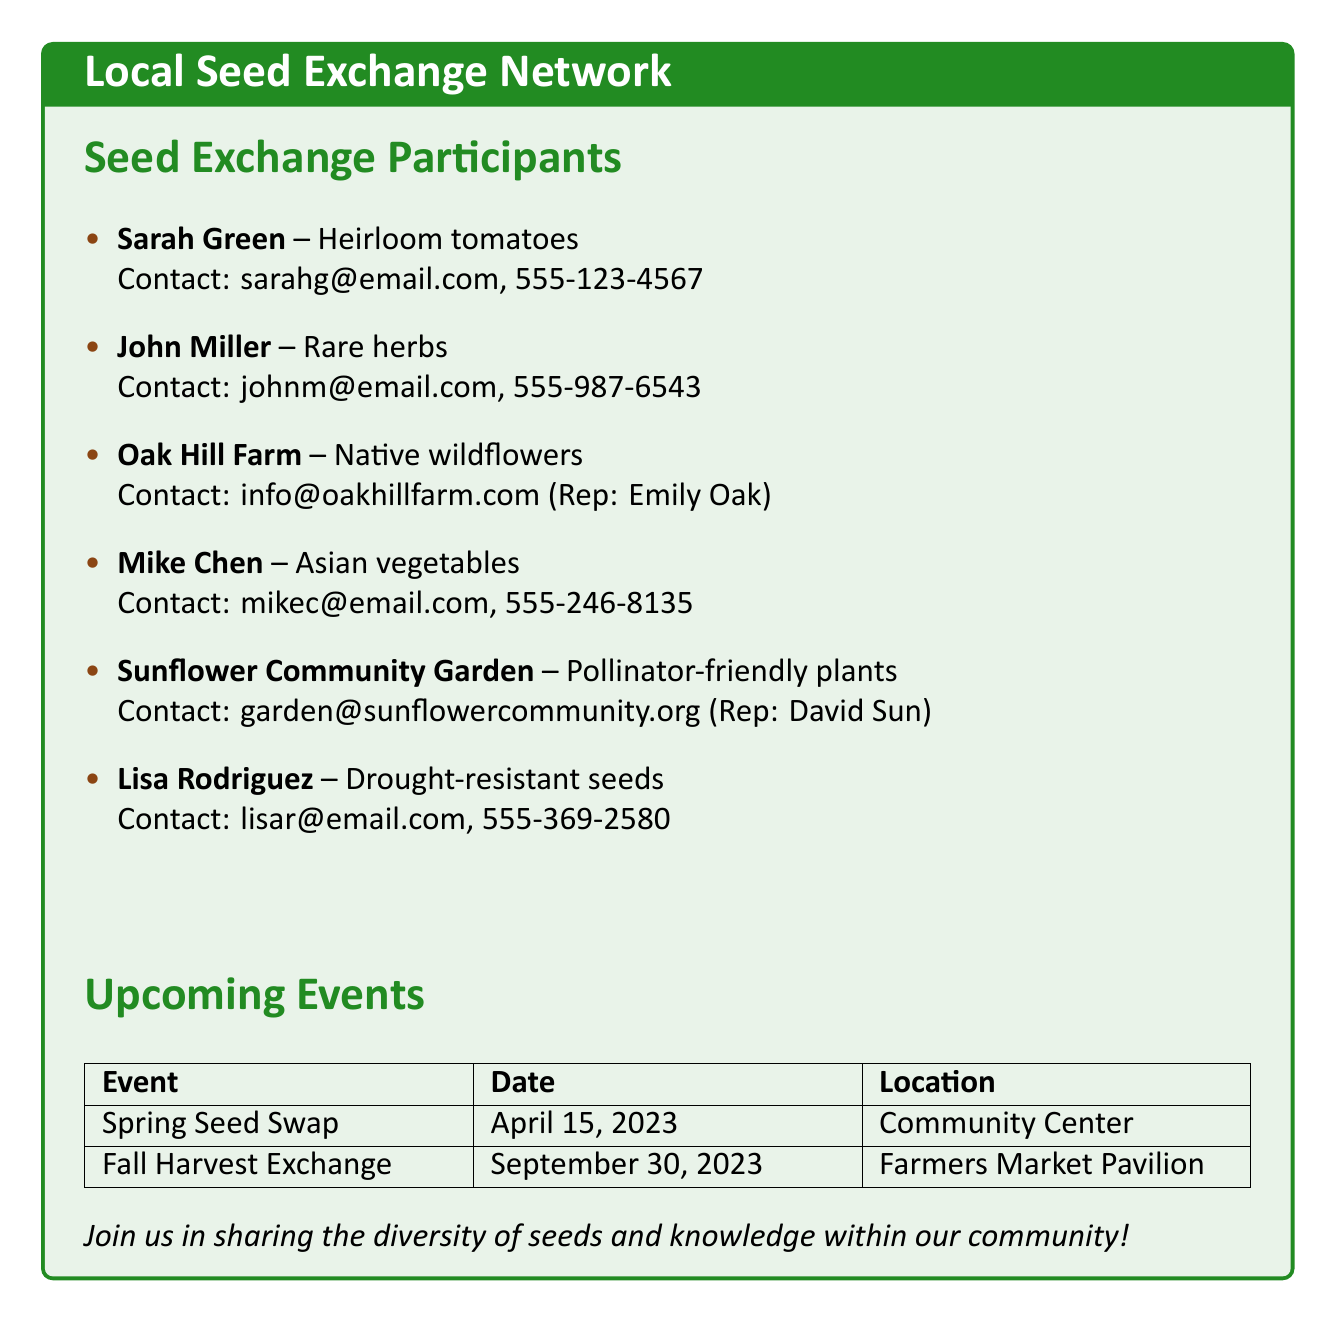What is Sarah Green's specialty? Sarah Green's specialty is found under her name in the participants' list.
Answer: Heirloom tomatoes What is John Miller's contact email? John's contact email is available next to his name in the document.
Answer: johnm@email.com Who represents Oak Hill Farm? The representative for Oak Hill Farm is mentioned in the contact details.
Answer: Emily Oak When is the Fall Harvest Exchange event? The date for the Fall Harvest Exchange is listed in the upcoming events section.
Answer: September 30, 2023 What type of plants does Sunflower Community Garden specialize in? The specialty of Sunflower Community Garden is listed alongside its name.
Answer: Pollinator-friendly plants How many participants are listed in the seed exchange? The total number of participants can be counted from the list provided in the document.
Answer: Six What is the location for the Spring Seed Swap? The location for the Spring Seed Swap is specified in the events section.
Answer: Community Center Which farmer specializes in drought-resistant seeds? The name of the participant specializing in drought-resistant seeds is detailed in the participants' section.
Answer: Lisa Rodriguez 